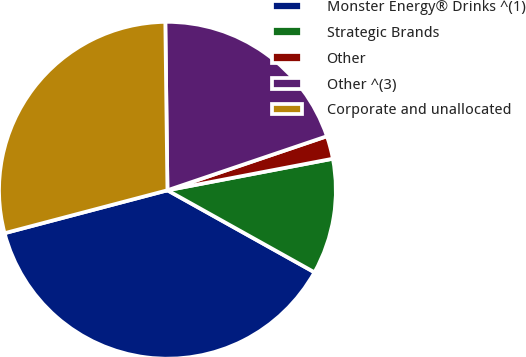Convert chart to OTSL. <chart><loc_0><loc_0><loc_500><loc_500><pie_chart><fcel>Monster Energy® Drinks ^(1)<fcel>Strategic Brands<fcel>Other<fcel>Other ^(3)<fcel>Corporate and unallocated<nl><fcel>37.8%<fcel>11.1%<fcel>2.2%<fcel>20.0%<fcel>28.9%<nl></chart> 